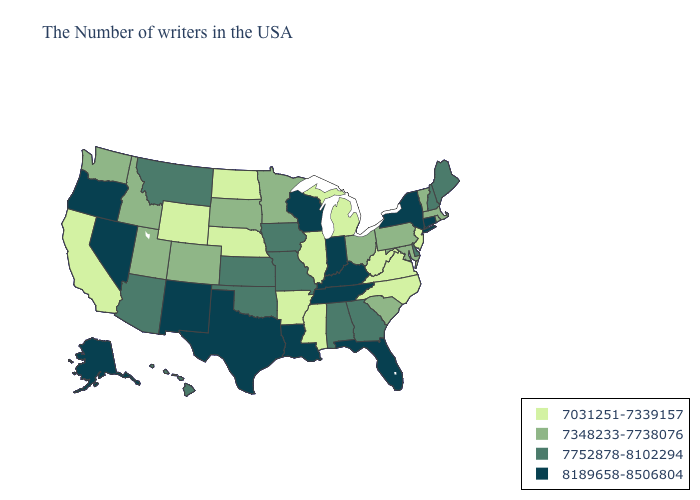Does Kentucky have the same value as Kansas?
Be succinct. No. What is the value of New York?
Short answer required. 8189658-8506804. Does Georgia have the same value as Arkansas?
Be succinct. No. What is the lowest value in states that border Washington?
Write a very short answer. 7348233-7738076. What is the value of Alabama?
Give a very brief answer. 7752878-8102294. What is the value of Maine?
Concise answer only. 7752878-8102294. Does Texas have the highest value in the USA?
Answer briefly. Yes. Is the legend a continuous bar?
Short answer required. No. Does South Carolina have the lowest value in the USA?
Answer briefly. No. Among the states that border Virginia , does Maryland have the lowest value?
Answer briefly. No. Does New Jersey have the lowest value in the Northeast?
Give a very brief answer. Yes. Does West Virginia have the lowest value in the USA?
Quick response, please. Yes. Name the states that have a value in the range 7348233-7738076?
Quick response, please. Massachusetts, Rhode Island, Vermont, Maryland, Pennsylvania, South Carolina, Ohio, Minnesota, South Dakota, Colorado, Utah, Idaho, Washington. What is the value of Massachusetts?
Write a very short answer. 7348233-7738076. Among the states that border South Carolina , which have the lowest value?
Keep it brief. North Carolina. 